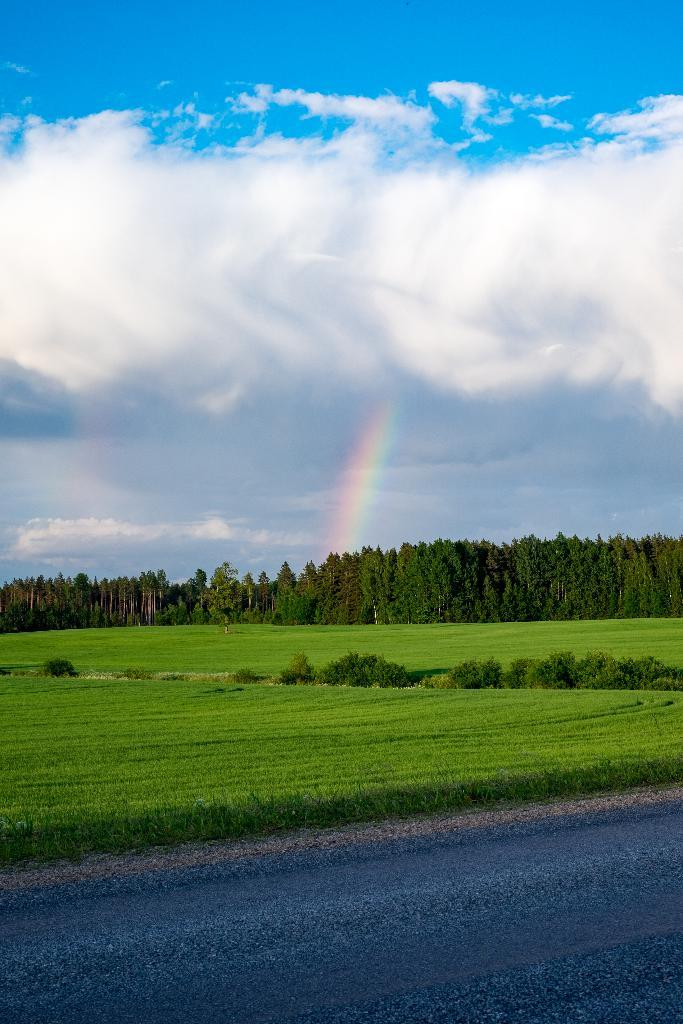What is located at the bottom of the picture? There is a road at the bottom of the picture. What type of vegetation is beside the road? There is grass beside the road. What can be seen in the background of the image? There are trees in the background of the image. What is visible at the top of the picture? The sky is visible at the top of the picture. What is the condition of the sky in the image? Clouds are present in the sky, and there is a rainbow visible. What type of stew is being cooked on the road in the image? There is no stew being cooked on the road in the image. What type of rod can be seen in the trees in the image? There is no rod visible in the trees in the image. 